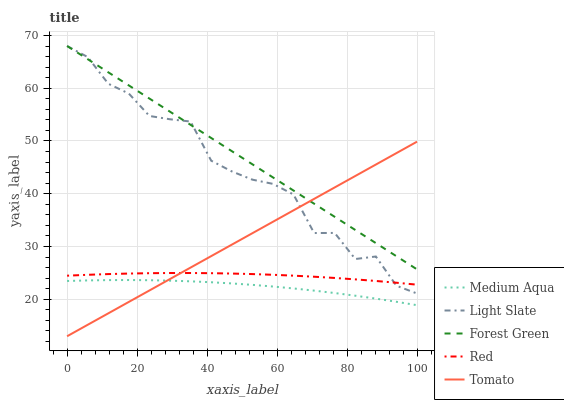Does Medium Aqua have the minimum area under the curve?
Answer yes or no. Yes. Does Forest Green have the maximum area under the curve?
Answer yes or no. Yes. Does Tomato have the minimum area under the curve?
Answer yes or no. No. Does Tomato have the maximum area under the curve?
Answer yes or no. No. Is Tomato the smoothest?
Answer yes or no. Yes. Is Light Slate the roughest?
Answer yes or no. Yes. Is Forest Green the smoothest?
Answer yes or no. No. Is Forest Green the roughest?
Answer yes or no. No. Does Tomato have the lowest value?
Answer yes or no. Yes. Does Forest Green have the lowest value?
Answer yes or no. No. Does Forest Green have the highest value?
Answer yes or no. Yes. Does Tomato have the highest value?
Answer yes or no. No. Is Red less than Forest Green?
Answer yes or no. Yes. Is Forest Green greater than Red?
Answer yes or no. Yes. Does Tomato intersect Forest Green?
Answer yes or no. Yes. Is Tomato less than Forest Green?
Answer yes or no. No. Is Tomato greater than Forest Green?
Answer yes or no. No. Does Red intersect Forest Green?
Answer yes or no. No. 